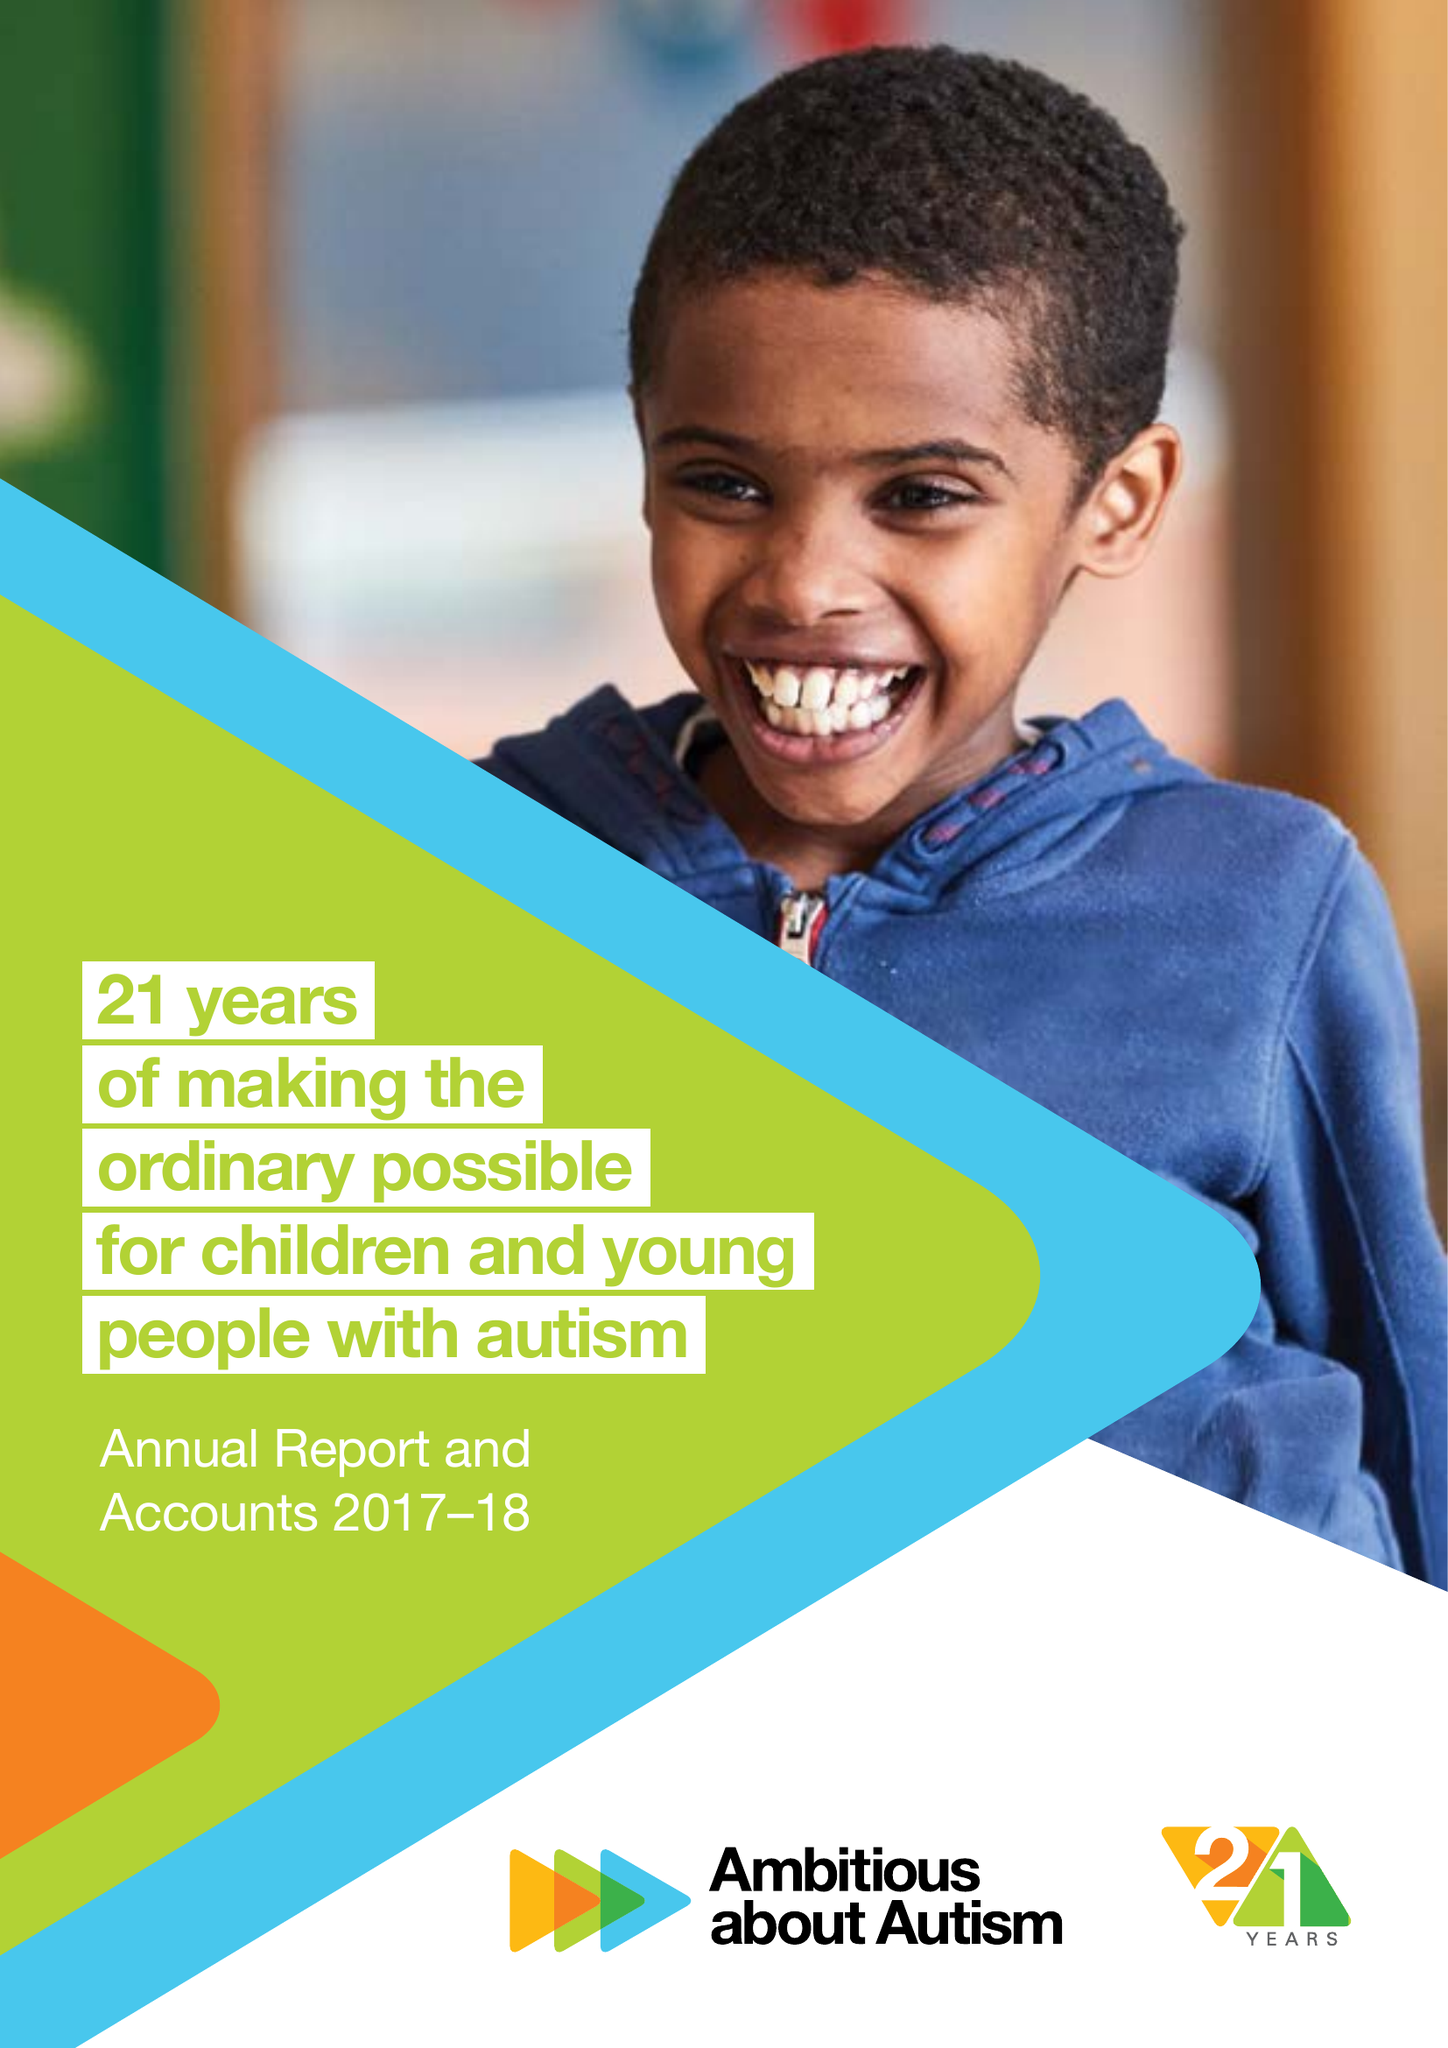What is the value for the charity_name?
Answer the question using a single word or phrase. Ambitious About Autism 